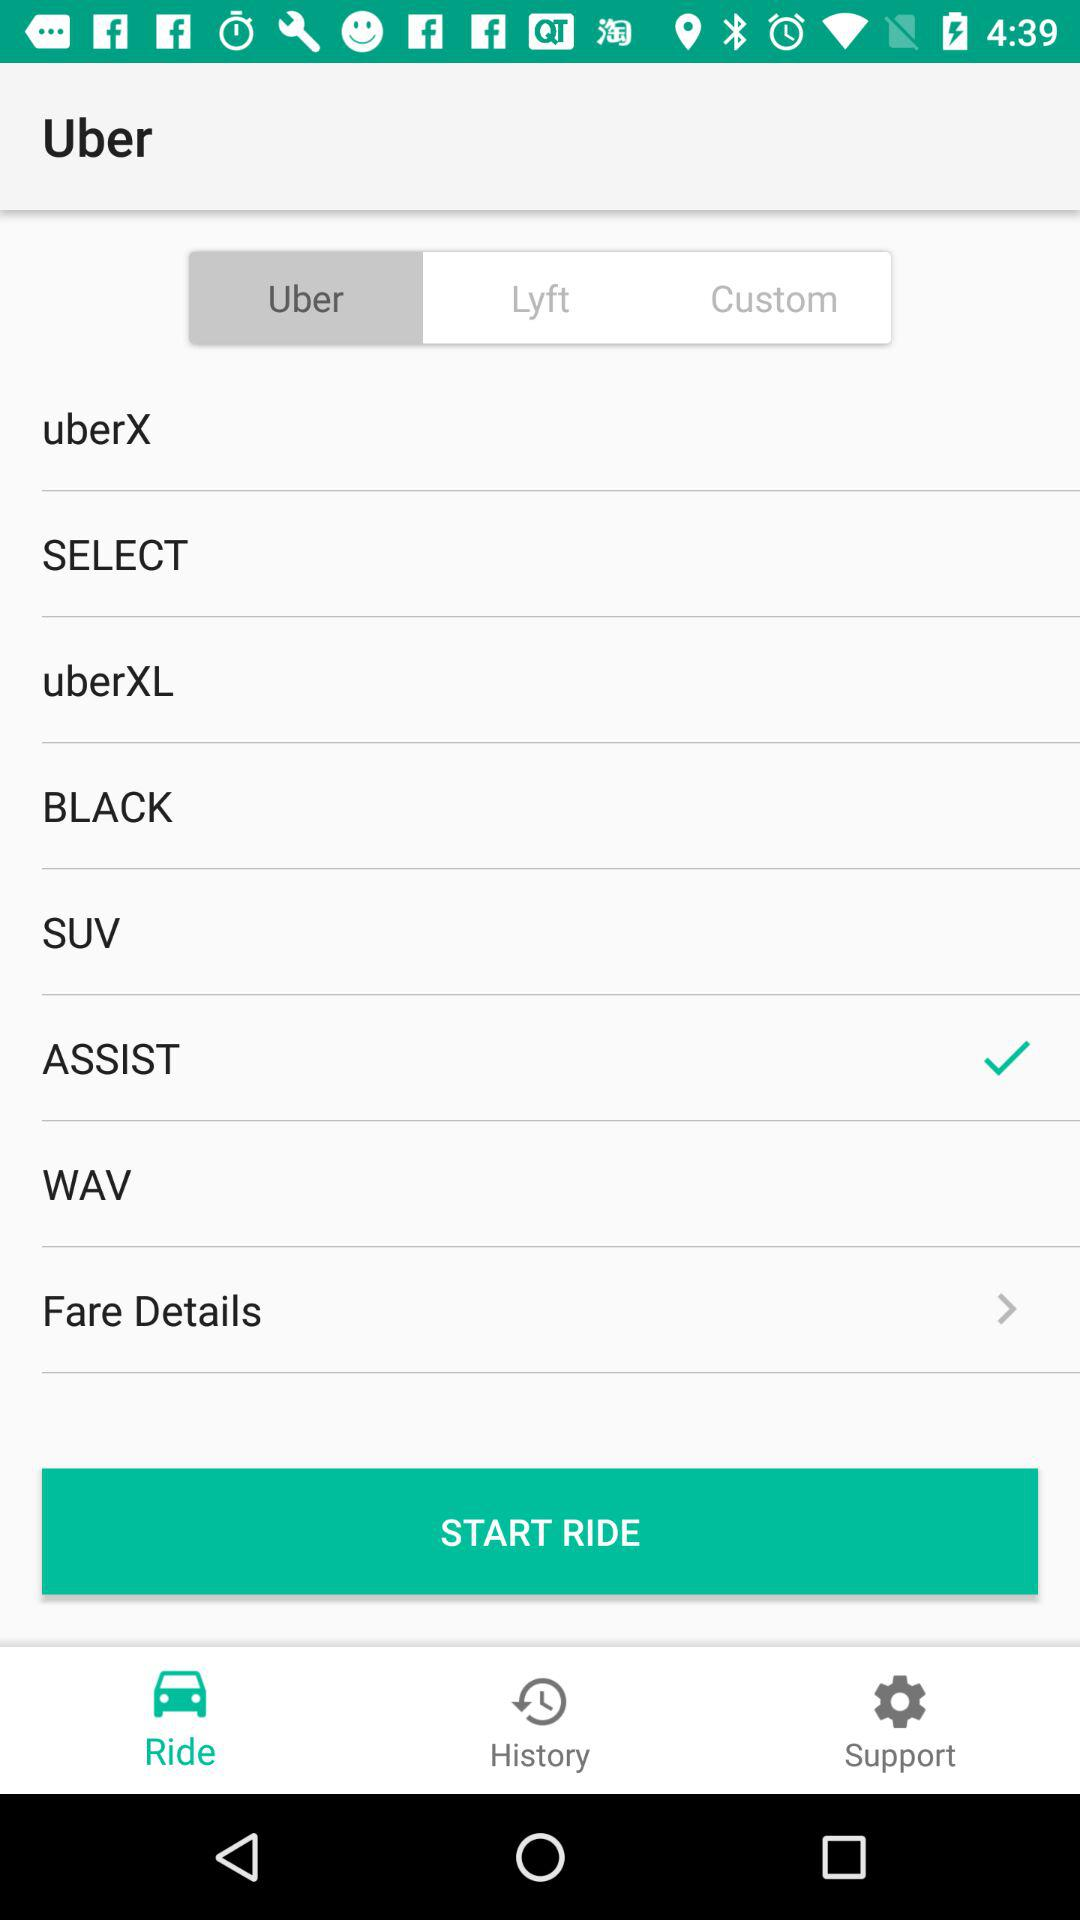Which tab am I now on? You are on the "Uber" and "Ride" tabs. 